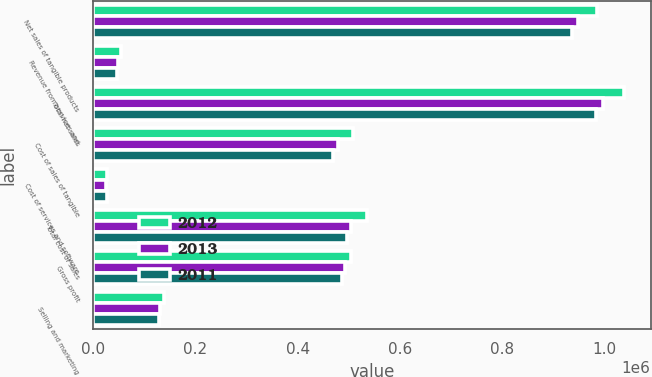<chart> <loc_0><loc_0><loc_500><loc_500><stacked_bar_chart><ecel><fcel>Net sales of tangible products<fcel>Revenue from services and<fcel>Total net sales<fcel>Cost of sales of tangible<fcel>Cost of services and software<fcel>Total cost of sales<fcel>Gross profit<fcel>Selling and marketing<nl><fcel>2012<fcel>984532<fcel>53627<fcel>1.03816e+06<fcel>507513<fcel>27036<fcel>535549<fcel>503610<fcel>138020<nl><fcel>2013<fcel>948227<fcel>47941<fcel>996168<fcel>479633<fcel>24891<fcel>504524<fcel>491644<fcel>129906<nl><fcel>2011<fcel>936282<fcel>47206<fcel>983488<fcel>469834<fcel>26885<fcel>496719<fcel>486769<fcel>127797<nl></chart> 